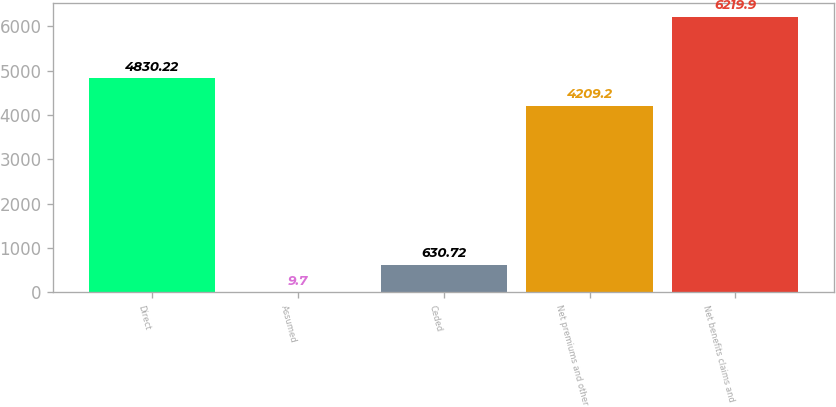Convert chart. <chart><loc_0><loc_0><loc_500><loc_500><bar_chart><fcel>Direct<fcel>Assumed<fcel>Ceded<fcel>Net premiums and other<fcel>Net benefits claims and<nl><fcel>4830.22<fcel>9.7<fcel>630.72<fcel>4209.2<fcel>6219.9<nl></chart> 